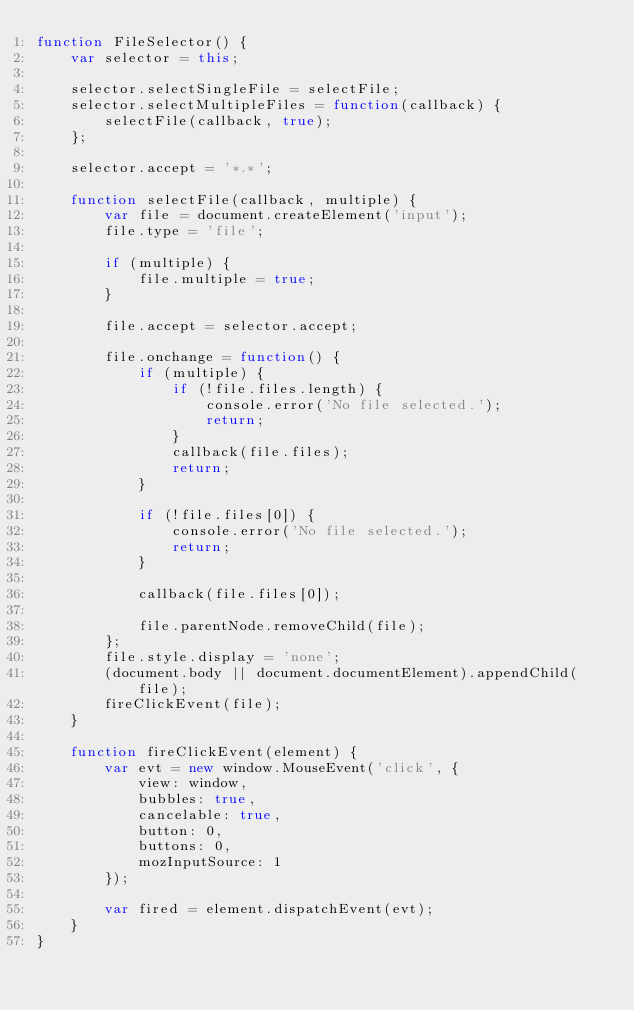<code> <loc_0><loc_0><loc_500><loc_500><_JavaScript_>function FileSelector() {
    var selector = this;

    selector.selectSingleFile = selectFile;
    selector.selectMultipleFiles = function(callback) {
        selectFile(callback, true);
    };

    selector.accept = '*.*';

    function selectFile(callback, multiple) {
        var file = document.createElement('input');
        file.type = 'file';

        if (multiple) {
            file.multiple = true;
        }

        file.accept = selector.accept;

        file.onchange = function() {
            if (multiple) {
                if (!file.files.length) {
                    console.error('No file selected.');
                    return;
                }
                callback(file.files);
                return;
            }

            if (!file.files[0]) {
                console.error('No file selected.');
                return;
            }

            callback(file.files[0]);

            file.parentNode.removeChild(file);
        };
        file.style.display = 'none';
        (document.body || document.documentElement).appendChild(file);
        fireClickEvent(file);
    }

    function fireClickEvent(element) {
        var evt = new window.MouseEvent('click', {
            view: window,
            bubbles: true,
            cancelable: true,
            button: 0,
            buttons: 0,
            mozInputSource: 1
        });

        var fired = element.dispatchEvent(evt);
    }
}
</code> 